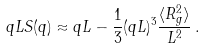Convert formula to latex. <formula><loc_0><loc_0><loc_500><loc_500>q L S ( q ) \approx q L - \frac { 1 } { 3 } ( q L ) ^ { 3 } \frac { \langle R _ { g } ^ { 2 } \rangle } { L ^ { 2 } } \, .</formula> 